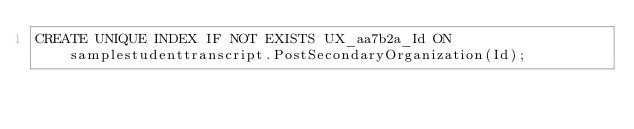Convert code to text. <code><loc_0><loc_0><loc_500><loc_500><_SQL_>CREATE UNIQUE INDEX IF NOT EXISTS UX_aa7b2a_Id ON samplestudenttranscript.PostSecondaryOrganization(Id);

</code> 